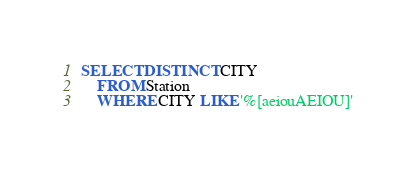<code> <loc_0><loc_0><loc_500><loc_500><_SQL_>SELECT DISTINCT CITY
    FROM Station
    WHERE CITY LIKE '%[aeiouAEIOU]'</code> 